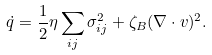Convert formula to latex. <formula><loc_0><loc_0><loc_500><loc_500>\dot { q } = \frac { 1 } { 2 } \eta \sum _ { i j } \sigma _ { i j } ^ { 2 } + \zeta _ { B } ( \nabla \cdot { v } ) ^ { 2 } .</formula> 